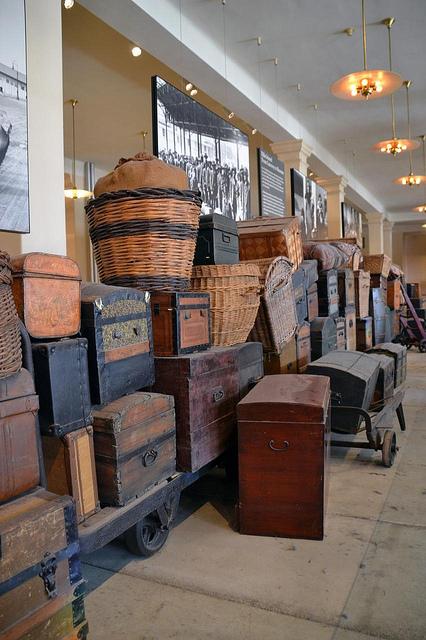What material makes up most of the objects shown?
Write a very short answer. Wood. What hardware makes it easier to pick up the heavy objects?
Be succinct. Forklift. How many wicker baskets are in the picture?
Keep it brief. 2. What color is the floor?
Be succinct. Brown. 